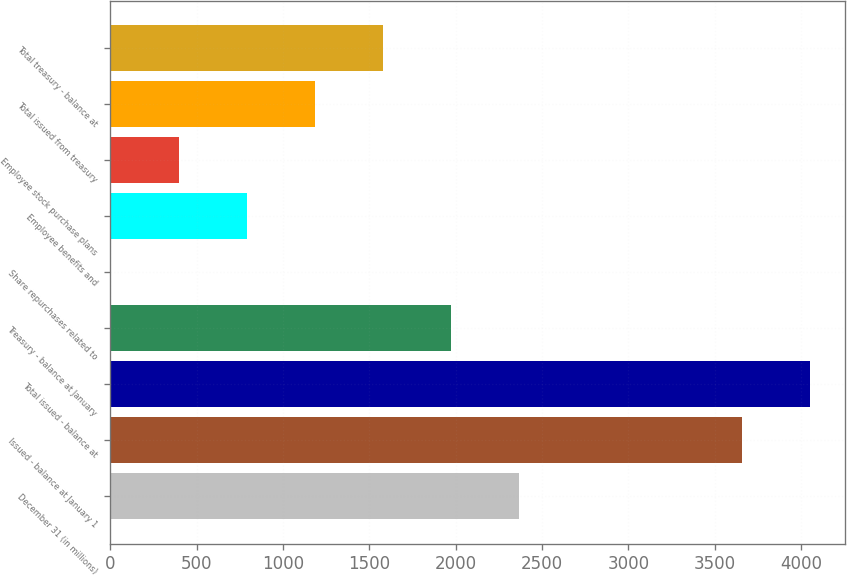Convert chart. <chart><loc_0><loc_0><loc_500><loc_500><bar_chart><fcel>December 31 (in millions)<fcel>Issued - balance at January 1<fcel>Total issued - balance at<fcel>Treasury - balance at January<fcel>Share repurchases related to<fcel>Employee benefits and<fcel>Employee stock purchase plans<fcel>Total issued from treasury<fcel>Total treasury - balance at<nl><fcel>2365.16<fcel>3657.7<fcel>4051.81<fcel>1971.05<fcel>0.5<fcel>788.72<fcel>394.61<fcel>1182.83<fcel>1576.94<nl></chart> 